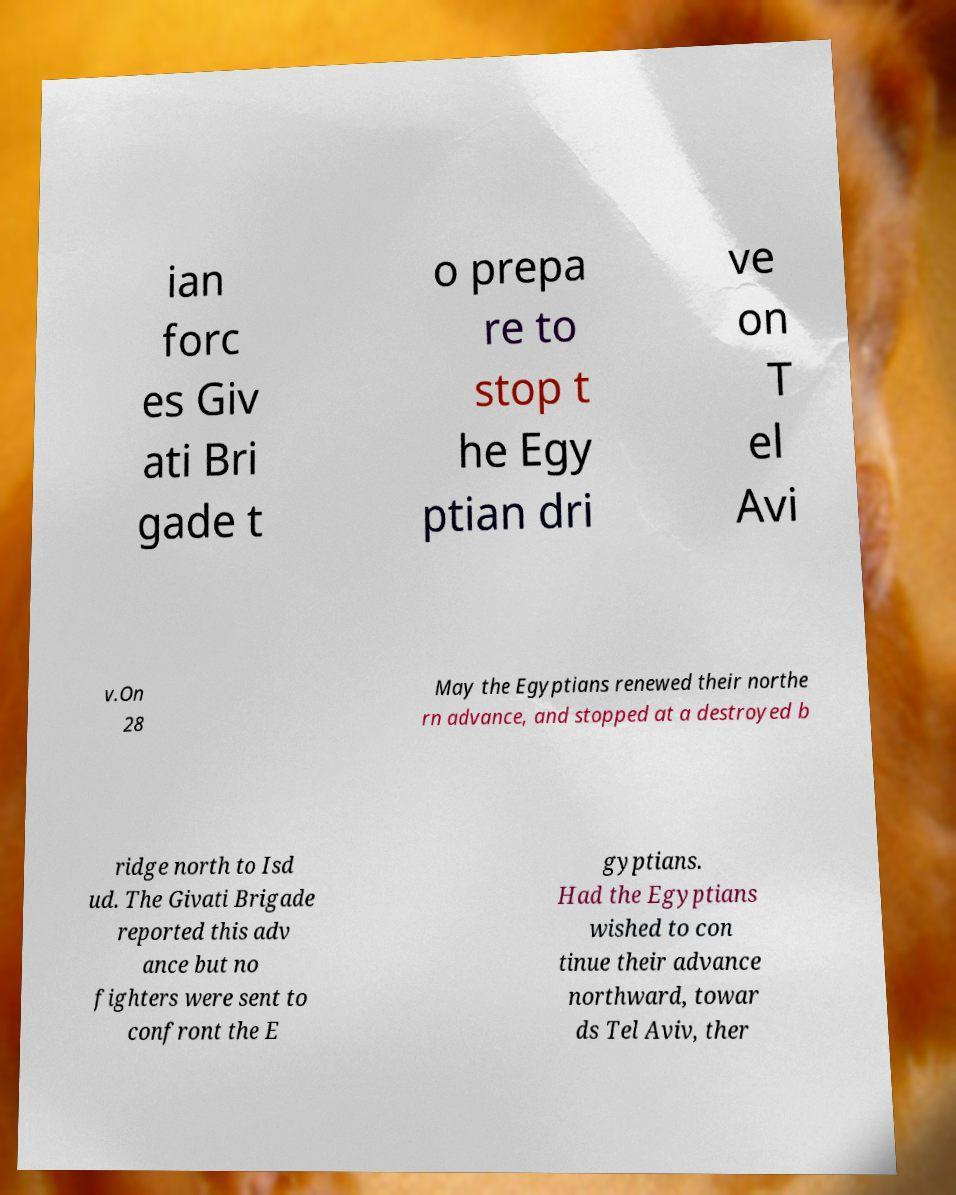Can you read and provide the text displayed in the image?This photo seems to have some interesting text. Can you extract and type it out for me? ian forc es Giv ati Bri gade t o prepa re to stop t he Egy ptian dri ve on T el Avi v.On 28 May the Egyptians renewed their northe rn advance, and stopped at a destroyed b ridge north to Isd ud. The Givati Brigade reported this adv ance but no fighters were sent to confront the E gyptians. Had the Egyptians wished to con tinue their advance northward, towar ds Tel Aviv, ther 